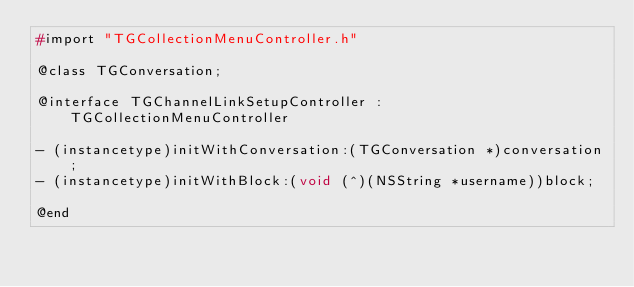Convert code to text. <code><loc_0><loc_0><loc_500><loc_500><_C_>#import "TGCollectionMenuController.h"

@class TGConversation;

@interface TGChannelLinkSetupController : TGCollectionMenuController

- (instancetype)initWithConversation:(TGConversation *)conversation;
- (instancetype)initWithBlock:(void (^)(NSString *username))block;

@end
</code> 